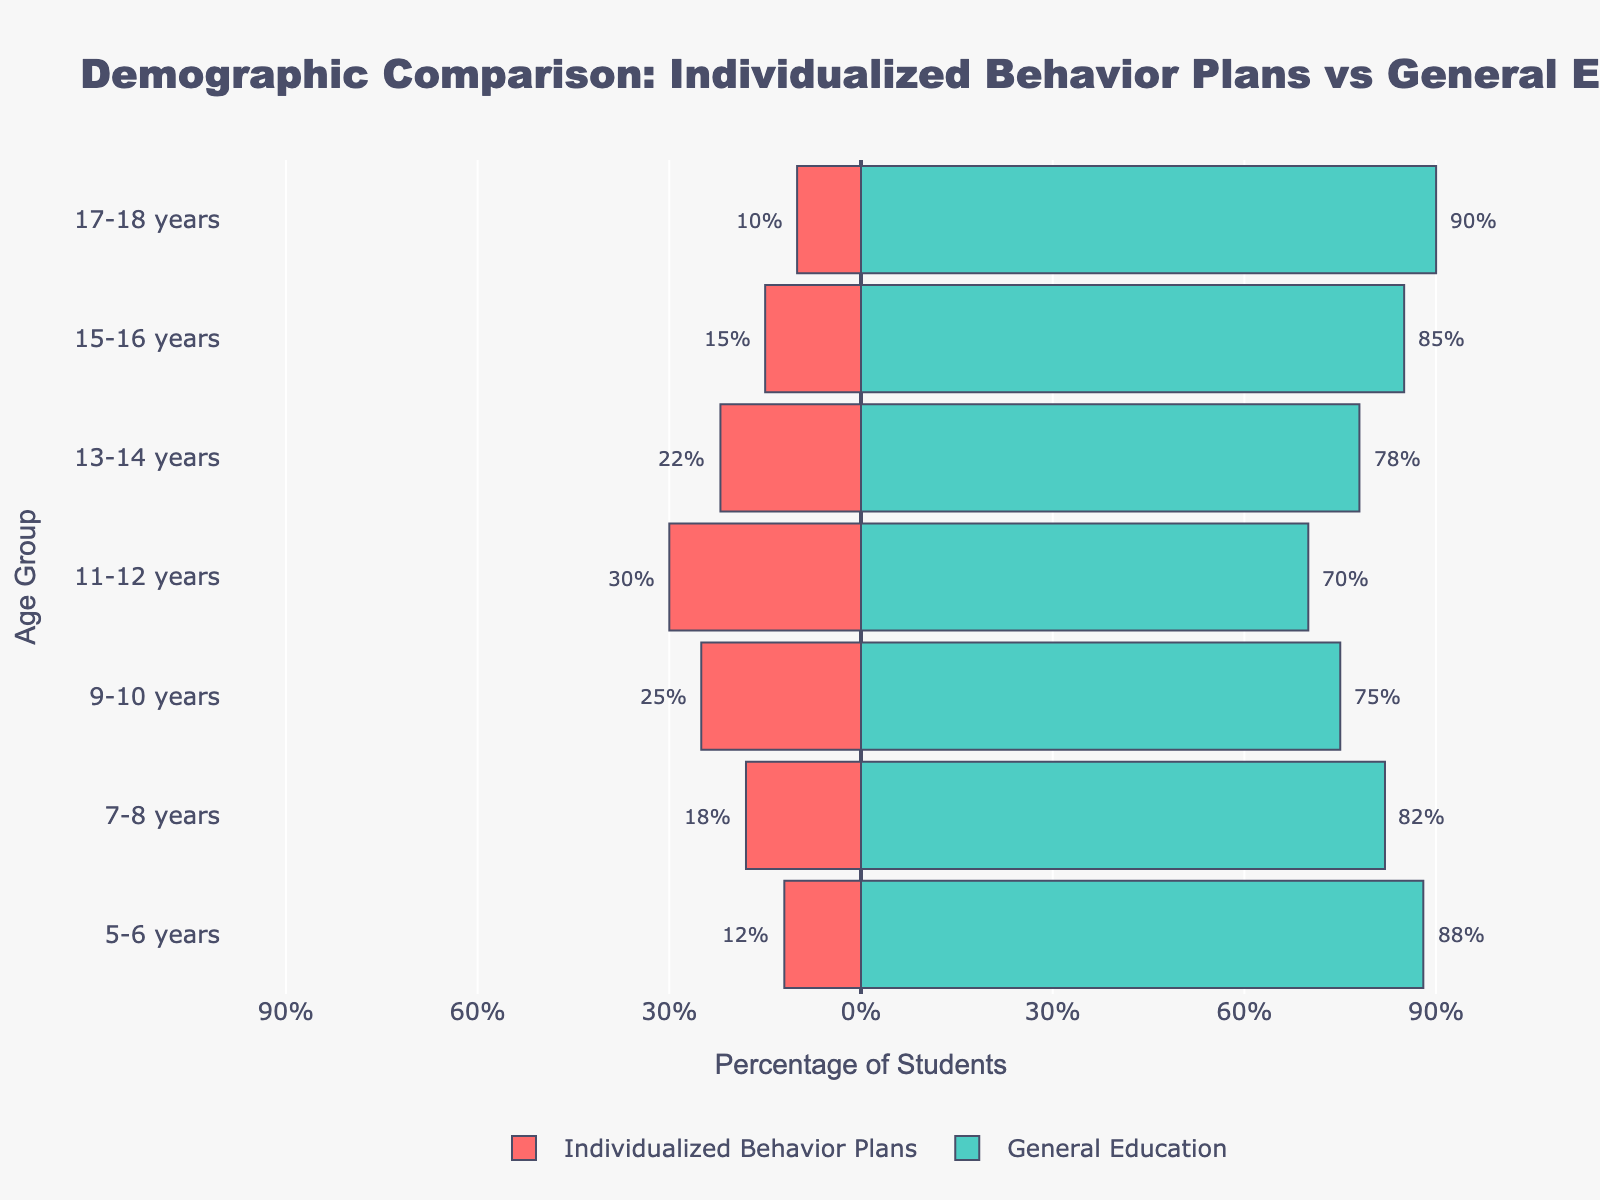How many age groups are displayed in the figure? Check the y-axis labels; these show the different age groups. Count the number of labels, which indicate the age groups.
Answer: 7 What percentage of students aged 15-16 years are in general education? Look at the bar corresponding to the 15-16 years age group and check the length and label of the green-colored bar on the right side. The label at the end of the bar indicates the percentage.
Answer: 85% Which age group has the highest percentage of students with individualized behavior plans? Identify the red bars on the left side and note their lengths. The age group with the longest red bar represents the highest percentage of students with individualized behavior plans.
Answer: 11-12 years What is the total percentage of students aged 5-6 years in both programs combined? Add the percentages from both bars (red for individualized behavior plans and green for general education) corresponding to the 5-6 years age group.
Answer: 100% How does the percentage of students with individualized behavior plans change from ages 9-10 years to 11-12 years? Compare the length and value of the red bars for the 9-10 years group and the 11-12 years group. Subtract the former's percentage from the latter's.
Answer: Increases by 5% In which age group is the difference between the two programs smallest? Calculate the absolute difference between the red and green bars for each age group. Identify the age group with the smallest difference.
Answer: 13-14 years Is there any age group where the percentage of students in general education is below 70%? Examine the green bars and their labels for each age group. Note if any of the percentages fall below 70%.
Answer: No What is the average percentage of students in general education across all age groups? Calculate the average of the percentages for general education across all age groups: (88+82+75+70+78+85+90) / 7.
Answer: Approximately 81% Which age group shows the greatest disparity between the two programs? Find the age group with the largest absolute difference between the percentages of students in the two programs.
Answer: 17-18 years How does the percentage of students in general education change as they get older? Observe the green bars and their lengths as the age groups progress from young to older. Determine if there is a pattern or trend, such as increasing, decreasing, or remaining constant.
Answer: Generally increases 